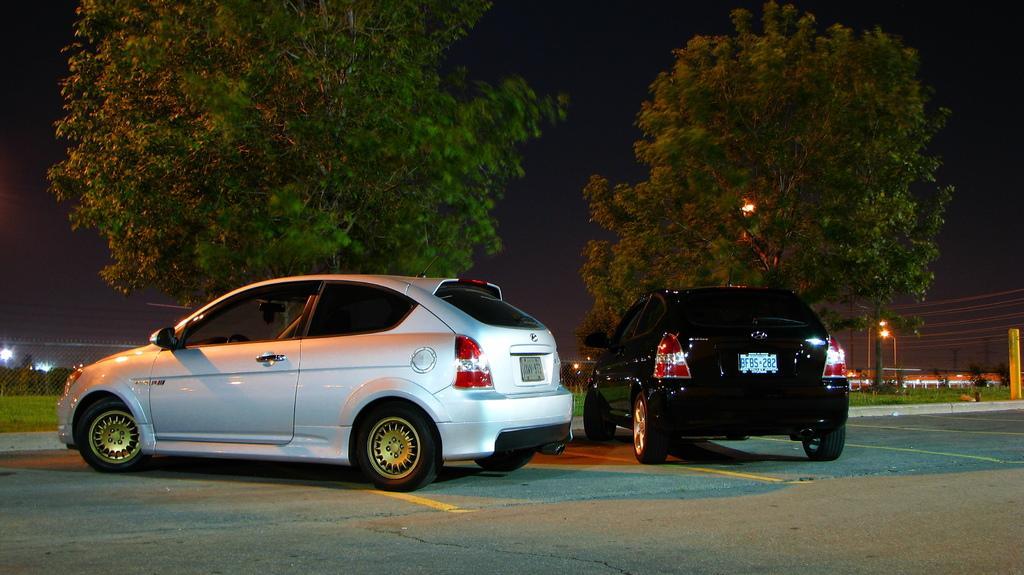Please provide a concise description of this image. In this image, we can see two cars are parked on the road. Background there is a mesh, plants, grass, poles, trees, lights. Here we can see dark view. 